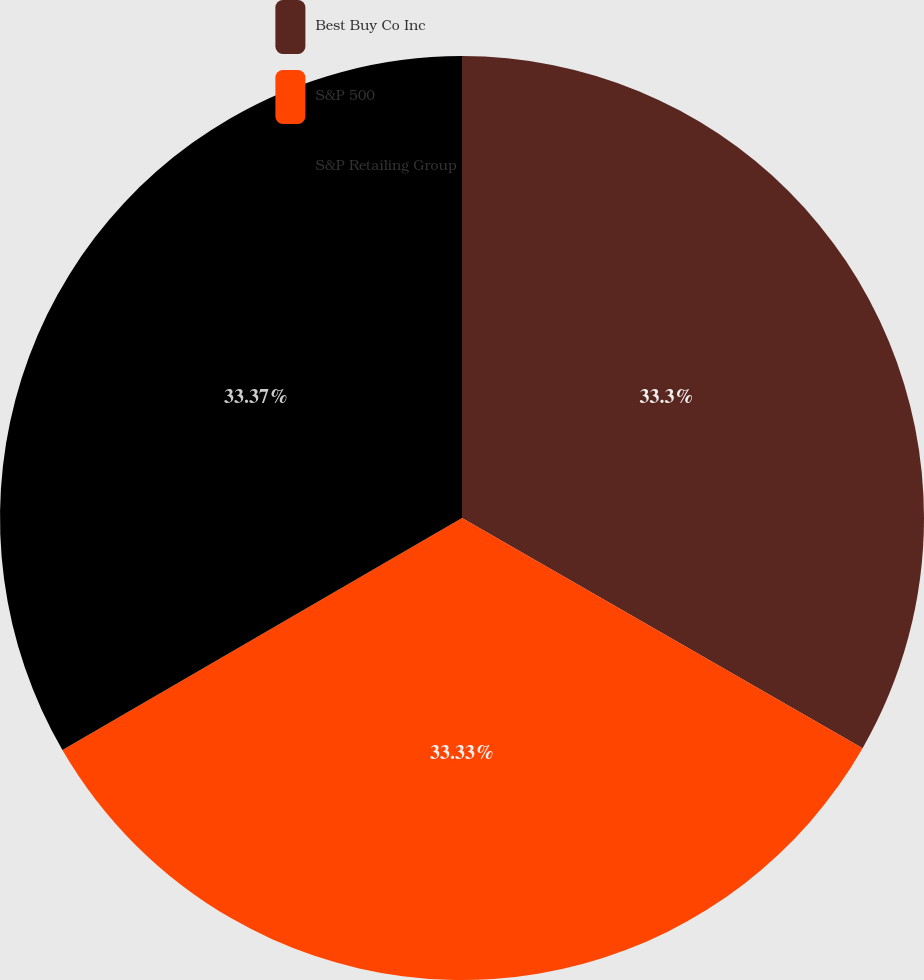Convert chart. <chart><loc_0><loc_0><loc_500><loc_500><pie_chart><fcel>Best Buy Co Inc<fcel>S&P 500<fcel>S&P Retailing Group<nl><fcel>33.3%<fcel>33.33%<fcel>33.37%<nl></chart> 